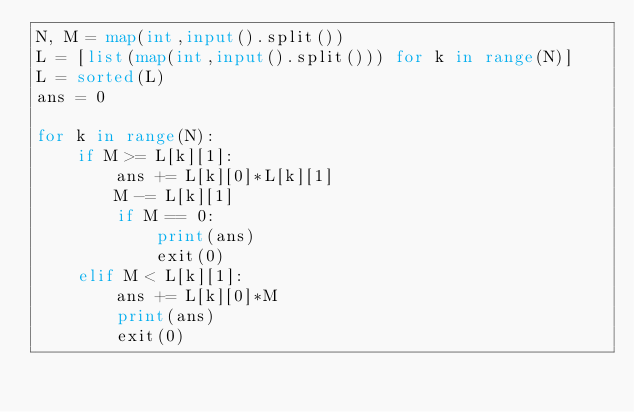Convert code to text. <code><loc_0><loc_0><loc_500><loc_500><_Python_>N, M = map(int,input().split())
L = [list(map(int,input().split())) for k in range(N)]
L = sorted(L)
ans = 0

for k in range(N):
    if M >= L[k][1]:
        ans += L[k][0]*L[k][1]
        M -= L[k][1]
        if M == 0:
            print(ans)
            exit(0)
    elif M < L[k][1]:
        ans += L[k][0]*M
        print(ans)
        exit(0)
</code> 